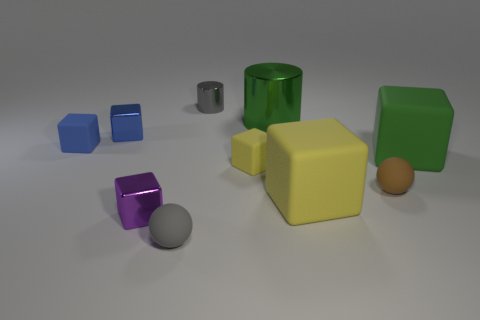Is the number of small gray shiny cylinders greater than the number of metal cylinders?
Give a very brief answer. No. What is the material of the green cube?
Ensure brevity in your answer.  Rubber. What is the color of the big block that is in front of the small yellow thing?
Make the answer very short. Yellow. Is the number of small yellow objects that are right of the brown matte thing greater than the number of tiny gray things that are behind the green matte object?
Provide a succinct answer. No. There is a metallic thing that is to the left of the purple metallic object that is behind the gray thing that is left of the tiny shiny cylinder; what is its size?
Give a very brief answer. Small. Is there a rubber ball that has the same color as the small cylinder?
Offer a terse response. Yes. What number of large cyan matte balls are there?
Provide a succinct answer. 0. What material is the small gray thing to the left of the tiny gray object that is behind the large matte cube that is in front of the small brown sphere?
Your response must be concise. Rubber. Are there any spheres made of the same material as the gray cylinder?
Your response must be concise. No. Are the large cylinder and the small purple object made of the same material?
Your answer should be compact. Yes. 